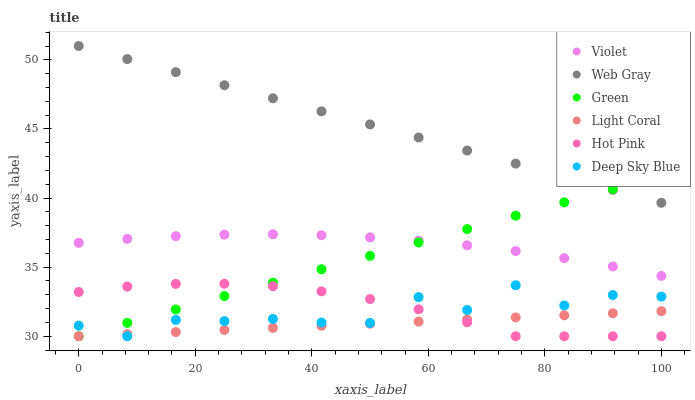Does Light Coral have the minimum area under the curve?
Answer yes or no. Yes. Does Web Gray have the maximum area under the curve?
Answer yes or no. Yes. Does Hot Pink have the minimum area under the curve?
Answer yes or no. No. Does Hot Pink have the maximum area under the curve?
Answer yes or no. No. Is Green the smoothest?
Answer yes or no. Yes. Is Deep Sky Blue the roughest?
Answer yes or no. Yes. Is Hot Pink the smoothest?
Answer yes or no. No. Is Hot Pink the roughest?
Answer yes or no. No. Does Hot Pink have the lowest value?
Answer yes or no. Yes. Does Violet have the lowest value?
Answer yes or no. No. Does Web Gray have the highest value?
Answer yes or no. Yes. Does Hot Pink have the highest value?
Answer yes or no. No. Is Hot Pink less than Violet?
Answer yes or no. Yes. Is Web Gray greater than Deep Sky Blue?
Answer yes or no. Yes. Does Deep Sky Blue intersect Light Coral?
Answer yes or no. Yes. Is Deep Sky Blue less than Light Coral?
Answer yes or no. No. Is Deep Sky Blue greater than Light Coral?
Answer yes or no. No. Does Hot Pink intersect Violet?
Answer yes or no. No. 